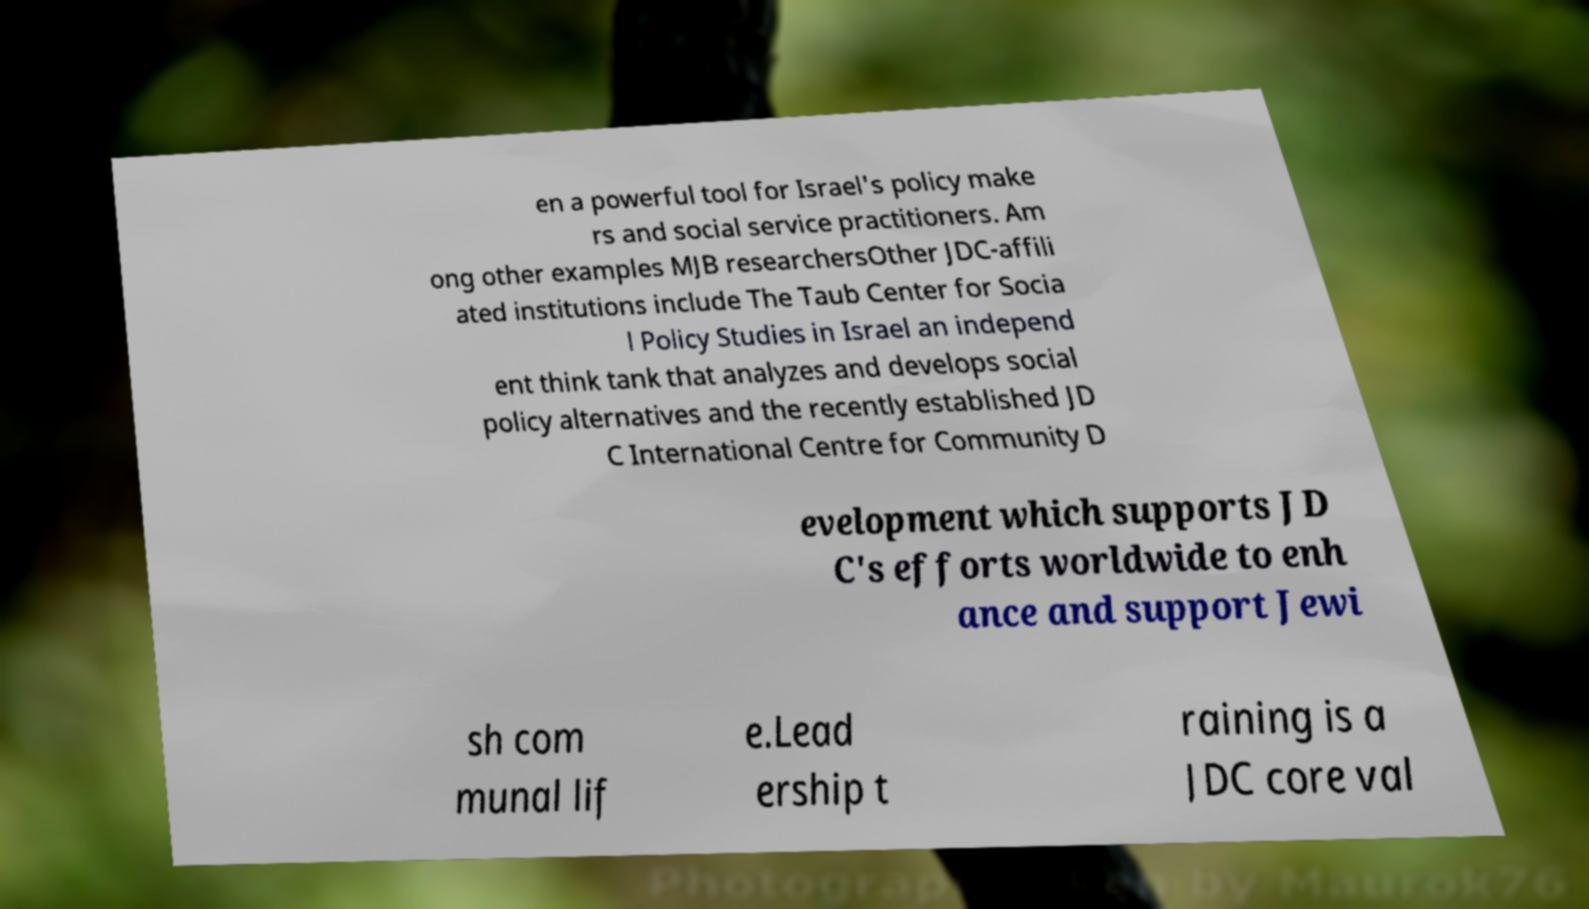For documentation purposes, I need the text within this image transcribed. Could you provide that? en a powerful tool for Israel's policy make rs and social service practitioners. Am ong other examples MJB researchersOther JDC-affili ated institutions include The Taub Center for Socia l Policy Studies in Israel an independ ent think tank that analyzes and develops social policy alternatives and the recently established JD C International Centre for Community D evelopment which supports JD C's efforts worldwide to enh ance and support Jewi sh com munal lif e.Lead ership t raining is a JDC core val 